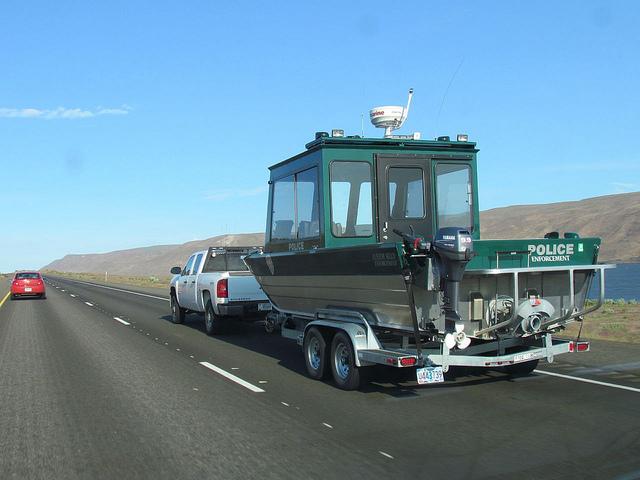Who are the owners of the boat?
Quick response, please. Police. What is in the left lane?
Give a very brief answer. Red car. What is pulling the boat?
Answer briefly. Truck. 